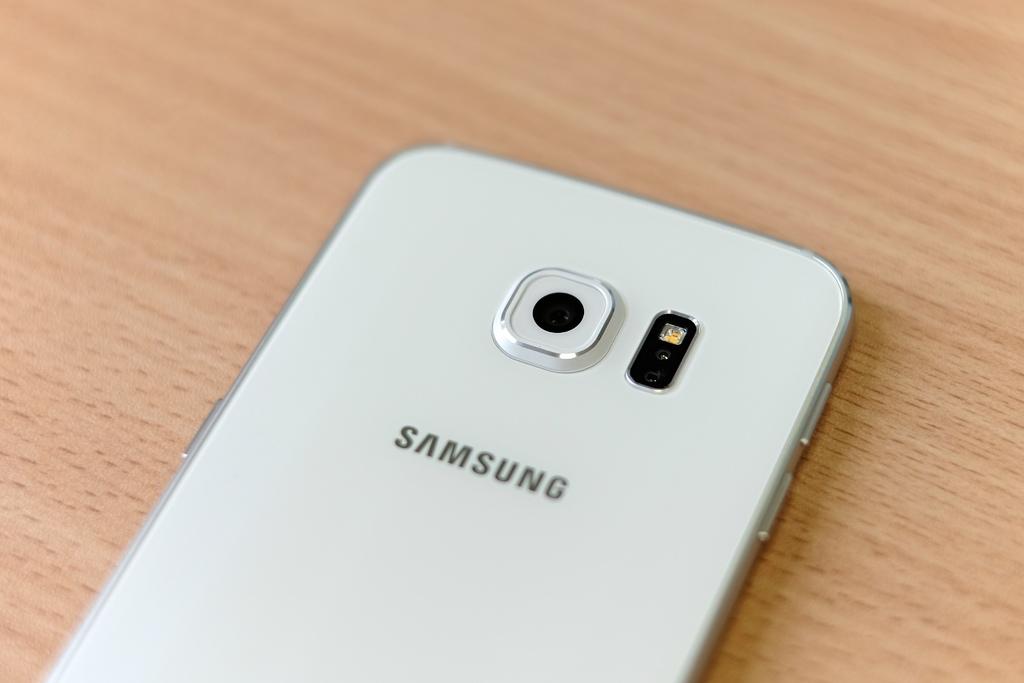What brand of phone is that?
Ensure brevity in your answer.  Samsung. The color of the samsung is?
Your answer should be very brief. Answering does not require reading text in the image. 